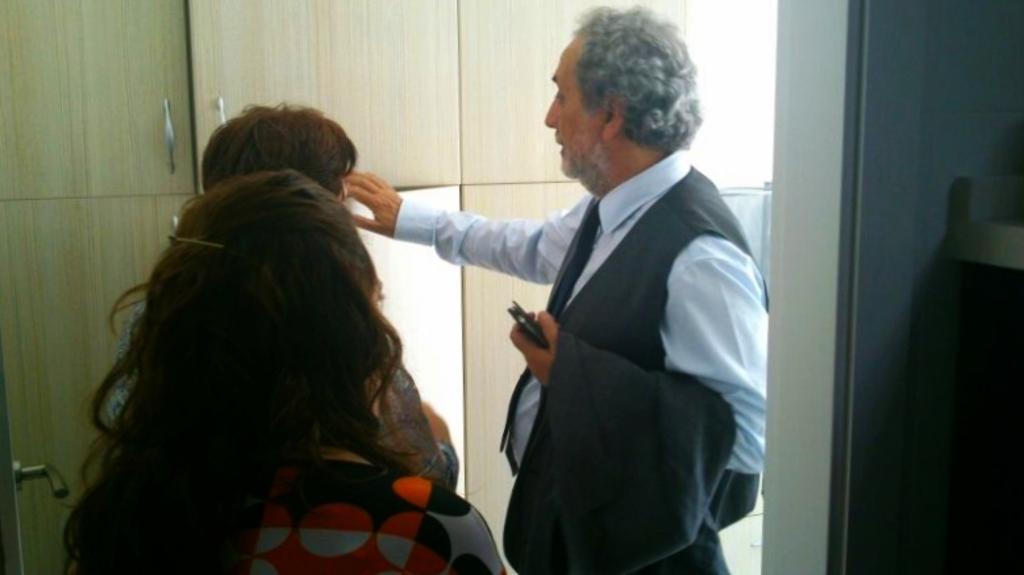Can you describe this image briefly? In this image we can see three persons, one of them is holding a cell phone, there are cupboards, and the wall. 